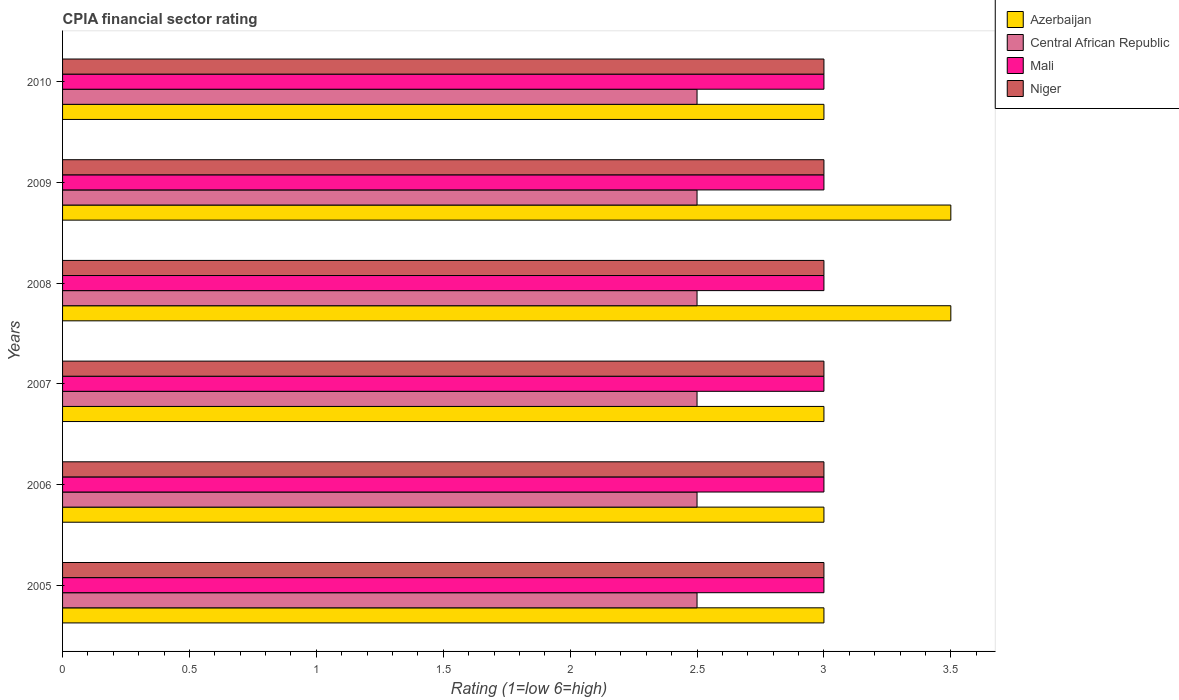How many groups of bars are there?
Ensure brevity in your answer.  6. Are the number of bars per tick equal to the number of legend labels?
Offer a terse response. Yes. Are the number of bars on each tick of the Y-axis equal?
Provide a short and direct response. Yes. How many bars are there on the 3rd tick from the top?
Make the answer very short. 4. Across all years, what is the maximum CPIA rating in Azerbaijan?
Provide a succinct answer. 3.5. Across all years, what is the minimum CPIA rating in Mali?
Your answer should be very brief. 3. What is the total CPIA rating in Azerbaijan in the graph?
Provide a succinct answer. 19. What is the difference between the CPIA rating in Central African Republic in 2009 and that in 2010?
Make the answer very short. 0. What is the average CPIA rating in Niger per year?
Your response must be concise. 3. In the year 2007, what is the difference between the CPIA rating in Central African Republic and CPIA rating in Azerbaijan?
Your answer should be compact. -0.5. In how many years, is the CPIA rating in Niger greater than 1.3 ?
Make the answer very short. 6. Is the CPIA rating in Mali in 2005 less than that in 2010?
Provide a succinct answer. No. Is the difference between the CPIA rating in Central African Republic in 2006 and 2009 greater than the difference between the CPIA rating in Azerbaijan in 2006 and 2009?
Keep it short and to the point. Yes. What is the difference between the highest and the second highest CPIA rating in Niger?
Provide a succinct answer. 0. In how many years, is the CPIA rating in Mali greater than the average CPIA rating in Mali taken over all years?
Provide a succinct answer. 0. Is the sum of the CPIA rating in Central African Republic in 2005 and 2007 greater than the maximum CPIA rating in Azerbaijan across all years?
Keep it short and to the point. Yes. What does the 2nd bar from the top in 2006 represents?
Provide a succinct answer. Mali. What does the 1st bar from the bottom in 2010 represents?
Offer a very short reply. Azerbaijan. Is it the case that in every year, the sum of the CPIA rating in Niger and CPIA rating in Mali is greater than the CPIA rating in Central African Republic?
Provide a succinct answer. Yes. How many bars are there?
Provide a succinct answer. 24. Are the values on the major ticks of X-axis written in scientific E-notation?
Provide a short and direct response. No. How are the legend labels stacked?
Your answer should be very brief. Vertical. What is the title of the graph?
Your response must be concise. CPIA financial sector rating. Does "El Salvador" appear as one of the legend labels in the graph?
Offer a very short reply. No. What is the Rating (1=low 6=high) in Azerbaijan in 2005?
Offer a very short reply. 3. What is the Rating (1=low 6=high) in Central African Republic in 2005?
Give a very brief answer. 2.5. What is the Rating (1=low 6=high) of Mali in 2006?
Provide a succinct answer. 3. What is the Rating (1=low 6=high) of Niger in 2006?
Your answer should be compact. 3. What is the Rating (1=low 6=high) in Azerbaijan in 2007?
Your response must be concise. 3. What is the Rating (1=low 6=high) in Niger in 2007?
Keep it short and to the point. 3. What is the Rating (1=low 6=high) of Central African Republic in 2008?
Give a very brief answer. 2.5. What is the Rating (1=low 6=high) in Azerbaijan in 2009?
Your answer should be compact. 3.5. What is the Rating (1=low 6=high) in Mali in 2009?
Offer a very short reply. 3. What is the Rating (1=low 6=high) in Niger in 2009?
Your answer should be compact. 3. What is the Rating (1=low 6=high) in Central African Republic in 2010?
Provide a succinct answer. 2.5. Across all years, what is the maximum Rating (1=low 6=high) in Azerbaijan?
Your answer should be very brief. 3.5. Across all years, what is the maximum Rating (1=low 6=high) of Central African Republic?
Offer a terse response. 2.5. Across all years, what is the maximum Rating (1=low 6=high) in Mali?
Your answer should be very brief. 3. Across all years, what is the maximum Rating (1=low 6=high) of Niger?
Keep it short and to the point. 3. Across all years, what is the minimum Rating (1=low 6=high) of Azerbaijan?
Provide a short and direct response. 3. Across all years, what is the minimum Rating (1=low 6=high) of Central African Republic?
Your response must be concise. 2.5. What is the total Rating (1=low 6=high) of Central African Republic in the graph?
Your response must be concise. 15. What is the difference between the Rating (1=low 6=high) of Azerbaijan in 2005 and that in 2006?
Your response must be concise. 0. What is the difference between the Rating (1=low 6=high) in Central African Republic in 2005 and that in 2007?
Keep it short and to the point. 0. What is the difference between the Rating (1=low 6=high) in Niger in 2005 and that in 2007?
Offer a very short reply. 0. What is the difference between the Rating (1=low 6=high) of Azerbaijan in 2005 and that in 2008?
Offer a terse response. -0.5. What is the difference between the Rating (1=low 6=high) of Mali in 2005 and that in 2008?
Ensure brevity in your answer.  0. What is the difference between the Rating (1=low 6=high) of Niger in 2005 and that in 2008?
Offer a very short reply. 0. What is the difference between the Rating (1=low 6=high) in Azerbaijan in 2005 and that in 2009?
Your response must be concise. -0.5. What is the difference between the Rating (1=low 6=high) of Mali in 2005 and that in 2009?
Make the answer very short. 0. What is the difference between the Rating (1=low 6=high) of Azerbaijan in 2006 and that in 2007?
Provide a short and direct response. 0. What is the difference between the Rating (1=low 6=high) in Mali in 2006 and that in 2007?
Give a very brief answer. 0. What is the difference between the Rating (1=low 6=high) of Niger in 2006 and that in 2007?
Your answer should be compact. 0. What is the difference between the Rating (1=low 6=high) of Azerbaijan in 2006 and that in 2008?
Your response must be concise. -0.5. What is the difference between the Rating (1=low 6=high) of Mali in 2006 and that in 2008?
Provide a succinct answer. 0. What is the difference between the Rating (1=low 6=high) of Azerbaijan in 2006 and that in 2009?
Provide a short and direct response. -0.5. What is the difference between the Rating (1=low 6=high) of Central African Republic in 2006 and that in 2009?
Provide a short and direct response. 0. What is the difference between the Rating (1=low 6=high) of Azerbaijan in 2006 and that in 2010?
Provide a succinct answer. 0. What is the difference between the Rating (1=low 6=high) in Mali in 2006 and that in 2010?
Your response must be concise. 0. What is the difference between the Rating (1=low 6=high) of Niger in 2006 and that in 2010?
Make the answer very short. 0. What is the difference between the Rating (1=low 6=high) in Azerbaijan in 2007 and that in 2008?
Keep it short and to the point. -0.5. What is the difference between the Rating (1=low 6=high) of Niger in 2007 and that in 2008?
Your response must be concise. 0. What is the difference between the Rating (1=low 6=high) of Azerbaijan in 2007 and that in 2009?
Keep it short and to the point. -0.5. What is the difference between the Rating (1=low 6=high) in Niger in 2007 and that in 2009?
Your answer should be compact. 0. What is the difference between the Rating (1=low 6=high) in Azerbaijan in 2007 and that in 2010?
Your answer should be very brief. 0. What is the difference between the Rating (1=low 6=high) in Central African Republic in 2007 and that in 2010?
Provide a short and direct response. 0. What is the difference between the Rating (1=low 6=high) in Niger in 2007 and that in 2010?
Offer a very short reply. 0. What is the difference between the Rating (1=low 6=high) in Central African Republic in 2008 and that in 2009?
Make the answer very short. 0. What is the difference between the Rating (1=low 6=high) in Mali in 2008 and that in 2009?
Make the answer very short. 0. What is the difference between the Rating (1=low 6=high) in Azerbaijan in 2008 and that in 2010?
Provide a succinct answer. 0.5. What is the difference between the Rating (1=low 6=high) of Mali in 2009 and that in 2010?
Provide a succinct answer. 0. What is the difference between the Rating (1=low 6=high) in Azerbaijan in 2005 and the Rating (1=low 6=high) in Niger in 2006?
Provide a succinct answer. 0. What is the difference between the Rating (1=low 6=high) of Central African Republic in 2005 and the Rating (1=low 6=high) of Mali in 2006?
Offer a very short reply. -0.5. What is the difference between the Rating (1=low 6=high) of Central African Republic in 2005 and the Rating (1=low 6=high) of Niger in 2006?
Your answer should be very brief. -0.5. What is the difference between the Rating (1=low 6=high) of Azerbaijan in 2005 and the Rating (1=low 6=high) of Mali in 2008?
Make the answer very short. 0. What is the difference between the Rating (1=low 6=high) in Central African Republic in 2005 and the Rating (1=low 6=high) in Niger in 2008?
Make the answer very short. -0.5. What is the difference between the Rating (1=low 6=high) in Azerbaijan in 2005 and the Rating (1=low 6=high) in Central African Republic in 2009?
Provide a succinct answer. 0.5. What is the difference between the Rating (1=low 6=high) of Azerbaijan in 2005 and the Rating (1=low 6=high) of Mali in 2009?
Ensure brevity in your answer.  0. What is the difference between the Rating (1=low 6=high) in Mali in 2005 and the Rating (1=low 6=high) in Niger in 2009?
Your answer should be compact. 0. What is the difference between the Rating (1=low 6=high) in Azerbaijan in 2005 and the Rating (1=low 6=high) in Mali in 2010?
Your response must be concise. 0. What is the difference between the Rating (1=low 6=high) in Azerbaijan in 2005 and the Rating (1=low 6=high) in Niger in 2010?
Your response must be concise. 0. What is the difference between the Rating (1=low 6=high) in Central African Republic in 2005 and the Rating (1=low 6=high) in Niger in 2010?
Provide a short and direct response. -0.5. What is the difference between the Rating (1=low 6=high) of Mali in 2005 and the Rating (1=low 6=high) of Niger in 2010?
Give a very brief answer. 0. What is the difference between the Rating (1=low 6=high) in Azerbaijan in 2006 and the Rating (1=low 6=high) in Mali in 2007?
Give a very brief answer. 0. What is the difference between the Rating (1=low 6=high) of Azerbaijan in 2006 and the Rating (1=low 6=high) of Niger in 2007?
Your answer should be compact. 0. What is the difference between the Rating (1=low 6=high) in Central African Republic in 2006 and the Rating (1=low 6=high) in Mali in 2007?
Your answer should be compact. -0.5. What is the difference between the Rating (1=low 6=high) in Central African Republic in 2006 and the Rating (1=low 6=high) in Niger in 2007?
Keep it short and to the point. -0.5. What is the difference between the Rating (1=low 6=high) in Mali in 2006 and the Rating (1=low 6=high) in Niger in 2007?
Make the answer very short. 0. What is the difference between the Rating (1=low 6=high) in Azerbaijan in 2006 and the Rating (1=low 6=high) in Central African Republic in 2008?
Give a very brief answer. 0.5. What is the difference between the Rating (1=low 6=high) in Azerbaijan in 2006 and the Rating (1=low 6=high) in Niger in 2008?
Offer a very short reply. 0. What is the difference between the Rating (1=low 6=high) of Central African Republic in 2006 and the Rating (1=low 6=high) of Mali in 2009?
Offer a terse response. -0.5. What is the difference between the Rating (1=low 6=high) in Central African Republic in 2006 and the Rating (1=low 6=high) in Niger in 2009?
Ensure brevity in your answer.  -0.5. What is the difference between the Rating (1=low 6=high) in Azerbaijan in 2006 and the Rating (1=low 6=high) in Central African Republic in 2010?
Offer a very short reply. 0.5. What is the difference between the Rating (1=low 6=high) of Azerbaijan in 2006 and the Rating (1=low 6=high) of Mali in 2010?
Offer a very short reply. 0. What is the difference between the Rating (1=low 6=high) of Mali in 2006 and the Rating (1=low 6=high) of Niger in 2010?
Make the answer very short. 0. What is the difference between the Rating (1=low 6=high) in Central African Republic in 2007 and the Rating (1=low 6=high) in Mali in 2008?
Make the answer very short. -0.5. What is the difference between the Rating (1=low 6=high) of Azerbaijan in 2007 and the Rating (1=low 6=high) of Central African Republic in 2009?
Ensure brevity in your answer.  0.5. What is the difference between the Rating (1=low 6=high) in Azerbaijan in 2007 and the Rating (1=low 6=high) in Niger in 2009?
Offer a terse response. 0. What is the difference between the Rating (1=low 6=high) of Central African Republic in 2007 and the Rating (1=low 6=high) of Niger in 2009?
Provide a short and direct response. -0.5. What is the difference between the Rating (1=low 6=high) of Central African Republic in 2007 and the Rating (1=low 6=high) of Niger in 2010?
Your answer should be compact. -0.5. What is the difference between the Rating (1=low 6=high) of Azerbaijan in 2008 and the Rating (1=low 6=high) of Niger in 2009?
Your answer should be very brief. 0.5. What is the difference between the Rating (1=low 6=high) in Central African Republic in 2008 and the Rating (1=low 6=high) in Mali in 2009?
Offer a terse response. -0.5. What is the difference between the Rating (1=low 6=high) in Central African Republic in 2008 and the Rating (1=low 6=high) in Niger in 2009?
Ensure brevity in your answer.  -0.5. What is the difference between the Rating (1=low 6=high) of Azerbaijan in 2008 and the Rating (1=low 6=high) of Niger in 2010?
Keep it short and to the point. 0.5. What is the difference between the Rating (1=low 6=high) in Central African Republic in 2008 and the Rating (1=low 6=high) in Mali in 2010?
Provide a short and direct response. -0.5. What is the difference between the Rating (1=low 6=high) in Mali in 2008 and the Rating (1=low 6=high) in Niger in 2010?
Your answer should be very brief. 0. What is the difference between the Rating (1=low 6=high) in Azerbaijan in 2009 and the Rating (1=low 6=high) in Mali in 2010?
Provide a short and direct response. 0.5. What is the difference between the Rating (1=low 6=high) of Azerbaijan in 2009 and the Rating (1=low 6=high) of Niger in 2010?
Provide a succinct answer. 0.5. What is the average Rating (1=low 6=high) in Azerbaijan per year?
Offer a terse response. 3.17. What is the average Rating (1=low 6=high) of Central African Republic per year?
Your answer should be compact. 2.5. In the year 2005, what is the difference between the Rating (1=low 6=high) of Azerbaijan and Rating (1=low 6=high) of Niger?
Your response must be concise. 0. In the year 2005, what is the difference between the Rating (1=low 6=high) in Central African Republic and Rating (1=low 6=high) in Niger?
Offer a very short reply. -0.5. In the year 2006, what is the difference between the Rating (1=low 6=high) in Azerbaijan and Rating (1=low 6=high) in Central African Republic?
Your answer should be compact. 0.5. In the year 2006, what is the difference between the Rating (1=low 6=high) of Central African Republic and Rating (1=low 6=high) of Mali?
Your response must be concise. -0.5. In the year 2006, what is the difference between the Rating (1=low 6=high) in Central African Republic and Rating (1=low 6=high) in Niger?
Your answer should be very brief. -0.5. In the year 2006, what is the difference between the Rating (1=low 6=high) in Mali and Rating (1=low 6=high) in Niger?
Keep it short and to the point. 0. In the year 2007, what is the difference between the Rating (1=low 6=high) in Azerbaijan and Rating (1=low 6=high) in Niger?
Ensure brevity in your answer.  0. In the year 2007, what is the difference between the Rating (1=low 6=high) of Mali and Rating (1=low 6=high) of Niger?
Offer a terse response. 0. In the year 2008, what is the difference between the Rating (1=low 6=high) in Azerbaijan and Rating (1=low 6=high) in Central African Republic?
Ensure brevity in your answer.  1. In the year 2008, what is the difference between the Rating (1=low 6=high) in Azerbaijan and Rating (1=low 6=high) in Niger?
Keep it short and to the point. 0.5. In the year 2009, what is the difference between the Rating (1=low 6=high) of Azerbaijan and Rating (1=low 6=high) of Central African Republic?
Your answer should be compact. 1. In the year 2009, what is the difference between the Rating (1=low 6=high) of Azerbaijan and Rating (1=low 6=high) of Mali?
Provide a short and direct response. 0.5. In the year 2009, what is the difference between the Rating (1=low 6=high) of Azerbaijan and Rating (1=low 6=high) of Niger?
Offer a very short reply. 0.5. In the year 2009, what is the difference between the Rating (1=low 6=high) in Central African Republic and Rating (1=low 6=high) in Niger?
Your answer should be very brief. -0.5. In the year 2010, what is the difference between the Rating (1=low 6=high) of Azerbaijan and Rating (1=low 6=high) of Mali?
Your response must be concise. 0. In the year 2010, what is the difference between the Rating (1=low 6=high) of Azerbaijan and Rating (1=low 6=high) of Niger?
Ensure brevity in your answer.  0. In the year 2010, what is the difference between the Rating (1=low 6=high) in Mali and Rating (1=low 6=high) in Niger?
Give a very brief answer. 0. What is the ratio of the Rating (1=low 6=high) in Mali in 2005 to that in 2006?
Provide a succinct answer. 1. What is the ratio of the Rating (1=low 6=high) in Azerbaijan in 2005 to that in 2007?
Provide a succinct answer. 1. What is the ratio of the Rating (1=low 6=high) of Central African Republic in 2005 to that in 2007?
Keep it short and to the point. 1. What is the ratio of the Rating (1=low 6=high) in Mali in 2005 to that in 2007?
Ensure brevity in your answer.  1. What is the ratio of the Rating (1=low 6=high) in Central African Republic in 2005 to that in 2008?
Your response must be concise. 1. What is the ratio of the Rating (1=low 6=high) of Mali in 2005 to that in 2008?
Offer a terse response. 1. What is the ratio of the Rating (1=low 6=high) in Azerbaijan in 2005 to that in 2009?
Your answer should be compact. 0.86. What is the ratio of the Rating (1=low 6=high) of Central African Republic in 2005 to that in 2009?
Provide a succinct answer. 1. What is the ratio of the Rating (1=low 6=high) of Niger in 2006 to that in 2007?
Provide a succinct answer. 1. What is the ratio of the Rating (1=low 6=high) of Azerbaijan in 2006 to that in 2008?
Ensure brevity in your answer.  0.86. What is the ratio of the Rating (1=low 6=high) of Central African Republic in 2006 to that in 2008?
Make the answer very short. 1. What is the ratio of the Rating (1=low 6=high) in Niger in 2006 to that in 2008?
Provide a succinct answer. 1. What is the ratio of the Rating (1=low 6=high) in Central African Republic in 2006 to that in 2010?
Your answer should be compact. 1. What is the ratio of the Rating (1=low 6=high) of Azerbaijan in 2007 to that in 2008?
Make the answer very short. 0.86. What is the ratio of the Rating (1=low 6=high) of Central African Republic in 2007 to that in 2008?
Provide a short and direct response. 1. What is the ratio of the Rating (1=low 6=high) in Mali in 2007 to that in 2008?
Your answer should be compact. 1. What is the ratio of the Rating (1=low 6=high) of Azerbaijan in 2007 to that in 2009?
Give a very brief answer. 0.86. What is the ratio of the Rating (1=low 6=high) in Mali in 2007 to that in 2009?
Provide a short and direct response. 1. What is the ratio of the Rating (1=low 6=high) of Mali in 2007 to that in 2010?
Offer a terse response. 1. What is the ratio of the Rating (1=low 6=high) of Niger in 2007 to that in 2010?
Your response must be concise. 1. What is the ratio of the Rating (1=low 6=high) of Mali in 2008 to that in 2010?
Provide a short and direct response. 1. What is the ratio of the Rating (1=low 6=high) in Niger in 2008 to that in 2010?
Provide a succinct answer. 1. What is the ratio of the Rating (1=low 6=high) in Mali in 2009 to that in 2010?
Your answer should be very brief. 1. What is the ratio of the Rating (1=low 6=high) of Niger in 2009 to that in 2010?
Provide a succinct answer. 1. What is the difference between the highest and the second highest Rating (1=low 6=high) in Azerbaijan?
Keep it short and to the point. 0. What is the difference between the highest and the second highest Rating (1=low 6=high) of Niger?
Offer a terse response. 0. What is the difference between the highest and the lowest Rating (1=low 6=high) in Mali?
Offer a very short reply. 0. What is the difference between the highest and the lowest Rating (1=low 6=high) in Niger?
Provide a short and direct response. 0. 